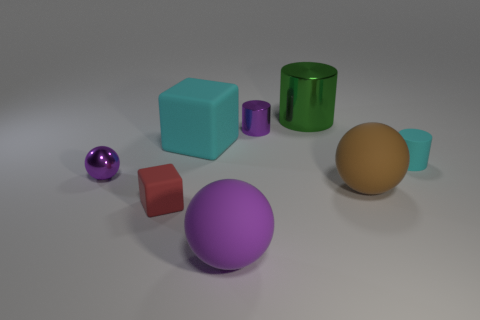Subtract all large matte balls. How many balls are left? 1 Subtract all purple cylinders. How many purple spheres are left? 2 Add 1 large things. How many objects exist? 9 Subtract all green cylinders. How many cylinders are left? 2 Subtract all balls. How many objects are left? 5 Add 3 large green cylinders. How many large green cylinders exist? 4 Subtract 0 red spheres. How many objects are left? 8 Subtract all red cylinders. Subtract all cyan cubes. How many cylinders are left? 3 Subtract all green cylinders. Subtract all red rubber things. How many objects are left? 6 Add 2 green things. How many green things are left? 3 